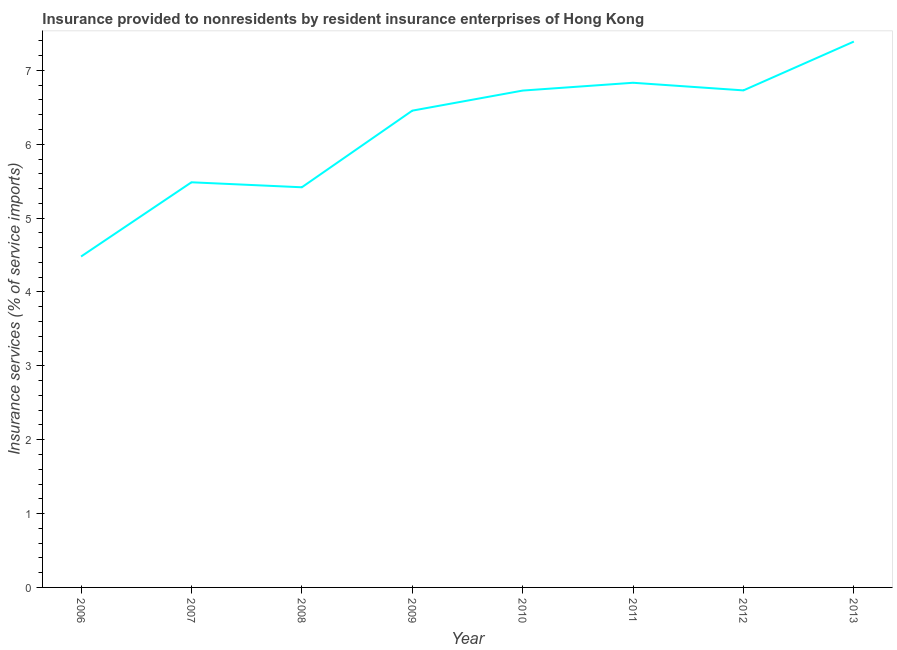What is the insurance and financial services in 2006?
Ensure brevity in your answer.  4.48. Across all years, what is the maximum insurance and financial services?
Your answer should be very brief. 7.39. Across all years, what is the minimum insurance and financial services?
Your response must be concise. 4.48. What is the sum of the insurance and financial services?
Provide a succinct answer. 49.52. What is the difference between the insurance and financial services in 2006 and 2007?
Provide a short and direct response. -1. What is the average insurance and financial services per year?
Provide a succinct answer. 6.19. What is the median insurance and financial services?
Keep it short and to the point. 6.59. In how many years, is the insurance and financial services greater than 6.6 %?
Make the answer very short. 4. Do a majority of the years between 2013 and 2009 (inclusive) have insurance and financial services greater than 6.6 %?
Provide a short and direct response. Yes. What is the ratio of the insurance and financial services in 2009 to that in 2011?
Give a very brief answer. 0.94. What is the difference between the highest and the second highest insurance and financial services?
Keep it short and to the point. 0.56. What is the difference between the highest and the lowest insurance and financial services?
Your response must be concise. 2.91. How many lines are there?
Ensure brevity in your answer.  1. What is the title of the graph?
Your response must be concise. Insurance provided to nonresidents by resident insurance enterprises of Hong Kong. What is the label or title of the Y-axis?
Give a very brief answer. Insurance services (% of service imports). What is the Insurance services (% of service imports) in 2006?
Keep it short and to the point. 4.48. What is the Insurance services (% of service imports) of 2007?
Provide a succinct answer. 5.49. What is the Insurance services (% of service imports) of 2008?
Keep it short and to the point. 5.42. What is the Insurance services (% of service imports) of 2009?
Keep it short and to the point. 6.45. What is the Insurance services (% of service imports) in 2010?
Ensure brevity in your answer.  6.73. What is the Insurance services (% of service imports) in 2011?
Offer a very short reply. 6.83. What is the Insurance services (% of service imports) of 2012?
Offer a terse response. 6.73. What is the Insurance services (% of service imports) in 2013?
Provide a short and direct response. 7.39. What is the difference between the Insurance services (% of service imports) in 2006 and 2007?
Provide a short and direct response. -1. What is the difference between the Insurance services (% of service imports) in 2006 and 2008?
Your response must be concise. -0.94. What is the difference between the Insurance services (% of service imports) in 2006 and 2009?
Your response must be concise. -1.97. What is the difference between the Insurance services (% of service imports) in 2006 and 2010?
Provide a succinct answer. -2.25. What is the difference between the Insurance services (% of service imports) in 2006 and 2011?
Offer a very short reply. -2.35. What is the difference between the Insurance services (% of service imports) in 2006 and 2012?
Provide a succinct answer. -2.25. What is the difference between the Insurance services (% of service imports) in 2006 and 2013?
Your response must be concise. -2.91. What is the difference between the Insurance services (% of service imports) in 2007 and 2008?
Provide a succinct answer. 0.07. What is the difference between the Insurance services (% of service imports) in 2007 and 2009?
Ensure brevity in your answer.  -0.97. What is the difference between the Insurance services (% of service imports) in 2007 and 2010?
Keep it short and to the point. -1.24. What is the difference between the Insurance services (% of service imports) in 2007 and 2011?
Your response must be concise. -1.35. What is the difference between the Insurance services (% of service imports) in 2007 and 2012?
Your response must be concise. -1.24. What is the difference between the Insurance services (% of service imports) in 2007 and 2013?
Your answer should be compact. -1.91. What is the difference between the Insurance services (% of service imports) in 2008 and 2009?
Your answer should be very brief. -1.04. What is the difference between the Insurance services (% of service imports) in 2008 and 2010?
Your answer should be compact. -1.31. What is the difference between the Insurance services (% of service imports) in 2008 and 2011?
Provide a short and direct response. -1.42. What is the difference between the Insurance services (% of service imports) in 2008 and 2012?
Give a very brief answer. -1.31. What is the difference between the Insurance services (% of service imports) in 2008 and 2013?
Give a very brief answer. -1.97. What is the difference between the Insurance services (% of service imports) in 2009 and 2010?
Offer a very short reply. -0.27. What is the difference between the Insurance services (% of service imports) in 2009 and 2011?
Ensure brevity in your answer.  -0.38. What is the difference between the Insurance services (% of service imports) in 2009 and 2012?
Offer a terse response. -0.27. What is the difference between the Insurance services (% of service imports) in 2009 and 2013?
Your answer should be compact. -0.94. What is the difference between the Insurance services (% of service imports) in 2010 and 2011?
Ensure brevity in your answer.  -0.11. What is the difference between the Insurance services (% of service imports) in 2010 and 2012?
Your answer should be very brief. -0. What is the difference between the Insurance services (% of service imports) in 2010 and 2013?
Your answer should be very brief. -0.66. What is the difference between the Insurance services (% of service imports) in 2011 and 2012?
Provide a succinct answer. 0.1. What is the difference between the Insurance services (% of service imports) in 2011 and 2013?
Offer a terse response. -0.56. What is the difference between the Insurance services (% of service imports) in 2012 and 2013?
Provide a short and direct response. -0.66. What is the ratio of the Insurance services (% of service imports) in 2006 to that in 2007?
Make the answer very short. 0.82. What is the ratio of the Insurance services (% of service imports) in 2006 to that in 2008?
Make the answer very short. 0.83. What is the ratio of the Insurance services (% of service imports) in 2006 to that in 2009?
Your answer should be compact. 0.69. What is the ratio of the Insurance services (% of service imports) in 2006 to that in 2010?
Your answer should be compact. 0.67. What is the ratio of the Insurance services (% of service imports) in 2006 to that in 2011?
Offer a very short reply. 0.66. What is the ratio of the Insurance services (% of service imports) in 2006 to that in 2012?
Provide a short and direct response. 0.67. What is the ratio of the Insurance services (% of service imports) in 2006 to that in 2013?
Provide a succinct answer. 0.61. What is the ratio of the Insurance services (% of service imports) in 2007 to that in 2008?
Offer a terse response. 1.01. What is the ratio of the Insurance services (% of service imports) in 2007 to that in 2010?
Your response must be concise. 0.81. What is the ratio of the Insurance services (% of service imports) in 2007 to that in 2011?
Ensure brevity in your answer.  0.8. What is the ratio of the Insurance services (% of service imports) in 2007 to that in 2012?
Make the answer very short. 0.81. What is the ratio of the Insurance services (% of service imports) in 2007 to that in 2013?
Ensure brevity in your answer.  0.74. What is the ratio of the Insurance services (% of service imports) in 2008 to that in 2009?
Provide a short and direct response. 0.84. What is the ratio of the Insurance services (% of service imports) in 2008 to that in 2010?
Give a very brief answer. 0.81. What is the ratio of the Insurance services (% of service imports) in 2008 to that in 2011?
Your answer should be very brief. 0.79. What is the ratio of the Insurance services (% of service imports) in 2008 to that in 2012?
Your answer should be compact. 0.81. What is the ratio of the Insurance services (% of service imports) in 2008 to that in 2013?
Ensure brevity in your answer.  0.73. What is the ratio of the Insurance services (% of service imports) in 2009 to that in 2010?
Keep it short and to the point. 0.96. What is the ratio of the Insurance services (% of service imports) in 2009 to that in 2011?
Keep it short and to the point. 0.94. What is the ratio of the Insurance services (% of service imports) in 2009 to that in 2013?
Give a very brief answer. 0.87. What is the ratio of the Insurance services (% of service imports) in 2010 to that in 2011?
Ensure brevity in your answer.  0.98. What is the ratio of the Insurance services (% of service imports) in 2010 to that in 2013?
Make the answer very short. 0.91. What is the ratio of the Insurance services (% of service imports) in 2011 to that in 2013?
Make the answer very short. 0.93. What is the ratio of the Insurance services (% of service imports) in 2012 to that in 2013?
Give a very brief answer. 0.91. 